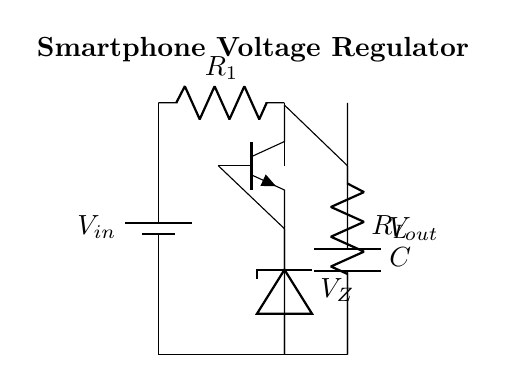what is the input voltage of this circuit? The input voltage is indicated by the label on the battery symbol and is denoted as V_in. This means it is the voltage provided to the circuit from an external source, typically a battery in a smartphone.
Answer: V_in what type of transistor is used in the circuit? The transistor is marked as "npn" in the diagram, which indicates that it is an NPN type of transistor. NPN transistors have three regions: emitter, base, and collector, facilitating current flow from the collector to the emitter.
Answer: npn what is the purpose of the Zener diode in this circuit? The Zener diode is used to maintain a stable output voltage by allowing current to flow in the reverse direction when the voltage exceeds a certain level, called V_Z. This helps to stabilize the output voltage for the connected load.
Answer: voltage regulation how many resistors are present in the circuit? The circuit diagram shows two distinct resistors labeled R_1 and R_L. These resistors are critical in determining the current and voltage levels across different components in the circuit.
Answer: 2 how does the capacitor contribute to this circuit? The capacitor connects between the output and ground, smoothing out voltage fluctuations and providing stability against transient changes in load. This helps maintain a steady output voltage, especially in dynamic load conditions.
Answer: smoothing what is the output voltage being provided by this regulator circuit? The output voltage is referenced as V_out in the circuit, which is the voltage across the load resistor R_L and is regulated by the combination of the transistor and the Zener diode. The specific value is determined by the circuit parameters but is not given numerically in this representation.
Answer: V_out 